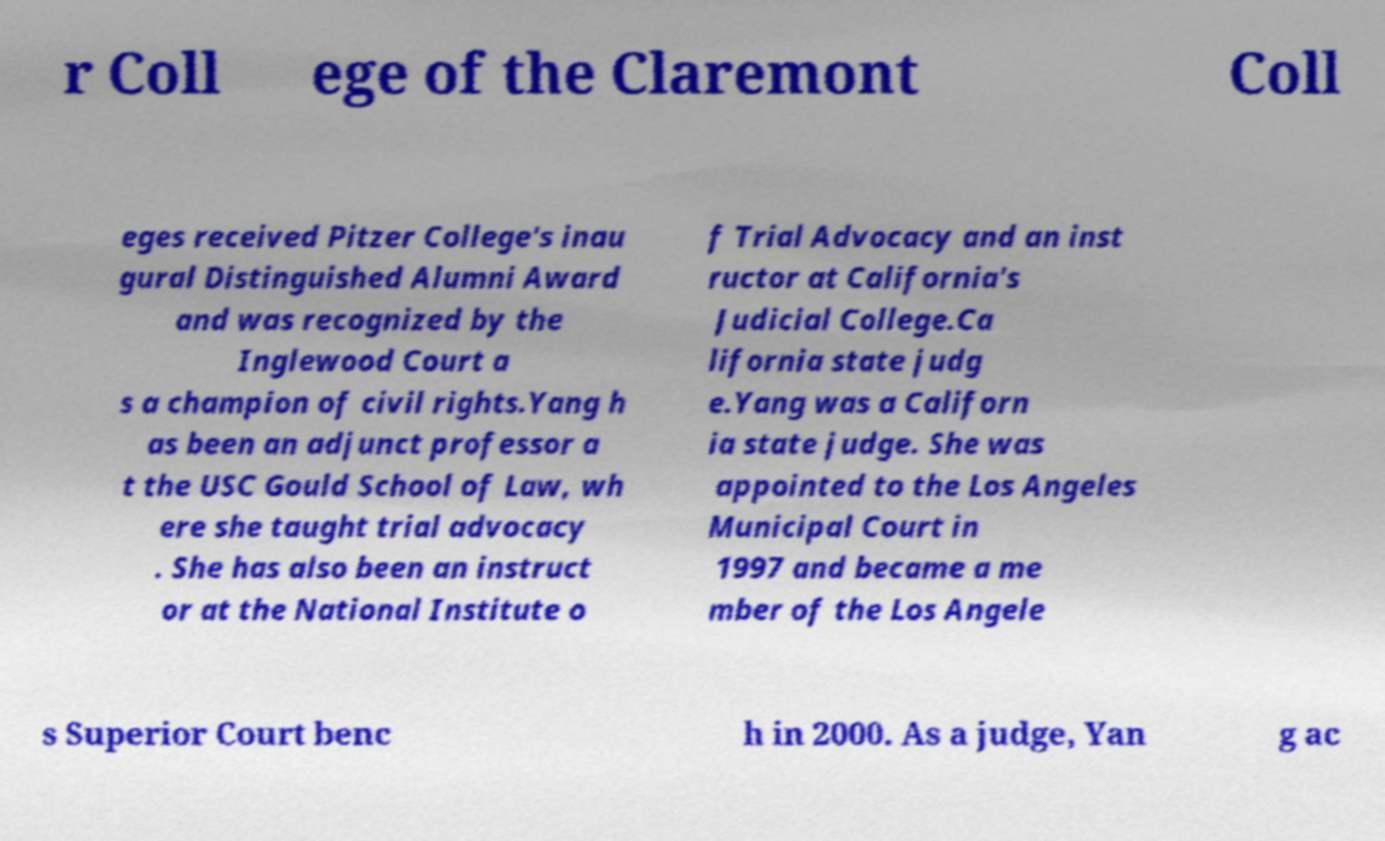Please read and relay the text visible in this image. What does it say? r Coll ege of the Claremont Coll eges received Pitzer College's inau gural Distinguished Alumni Award and was recognized by the Inglewood Court a s a champion of civil rights.Yang h as been an adjunct professor a t the USC Gould School of Law, wh ere she taught trial advocacy . She has also been an instruct or at the National Institute o f Trial Advocacy and an inst ructor at California's Judicial College.Ca lifornia state judg e.Yang was a Californ ia state judge. She was appointed to the Los Angeles Municipal Court in 1997 and became a me mber of the Los Angele s Superior Court benc h in 2000. As a judge, Yan g ac 